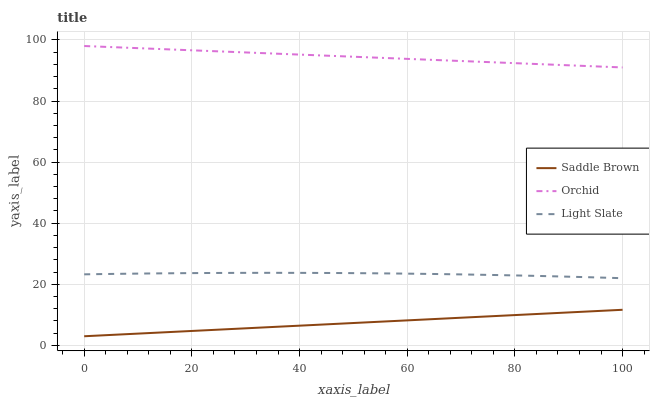Does Saddle Brown have the minimum area under the curve?
Answer yes or no. Yes. Does Orchid have the minimum area under the curve?
Answer yes or no. No. Does Saddle Brown have the maximum area under the curve?
Answer yes or no. No. Is Saddle Brown the smoothest?
Answer yes or no. Yes. Is Light Slate the roughest?
Answer yes or no. Yes. Is Orchid the smoothest?
Answer yes or no. No. Is Orchid the roughest?
Answer yes or no. No. Does Orchid have the lowest value?
Answer yes or no. No. Does Saddle Brown have the highest value?
Answer yes or no. No. Is Light Slate less than Orchid?
Answer yes or no. Yes. Is Orchid greater than Saddle Brown?
Answer yes or no. Yes. Does Light Slate intersect Orchid?
Answer yes or no. No. 